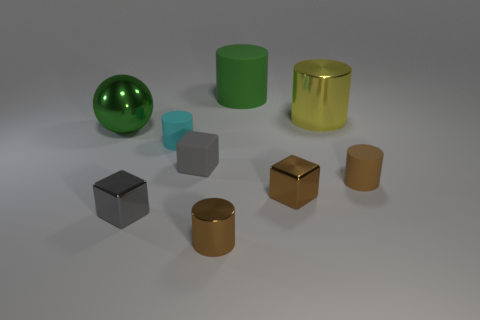Subtract 1 cylinders. How many cylinders are left? 4 Subtract all green cylinders. How many cylinders are left? 4 Subtract all green matte cylinders. How many cylinders are left? 4 Subtract all purple cylinders. Subtract all purple cubes. How many cylinders are left? 5 Subtract all cylinders. How many objects are left? 4 Subtract 0 gray balls. How many objects are left? 9 Subtract all tiny cyan shiny blocks. Subtract all spheres. How many objects are left? 8 Add 4 small metal cylinders. How many small metal cylinders are left? 5 Add 2 tiny brown objects. How many tiny brown objects exist? 5 